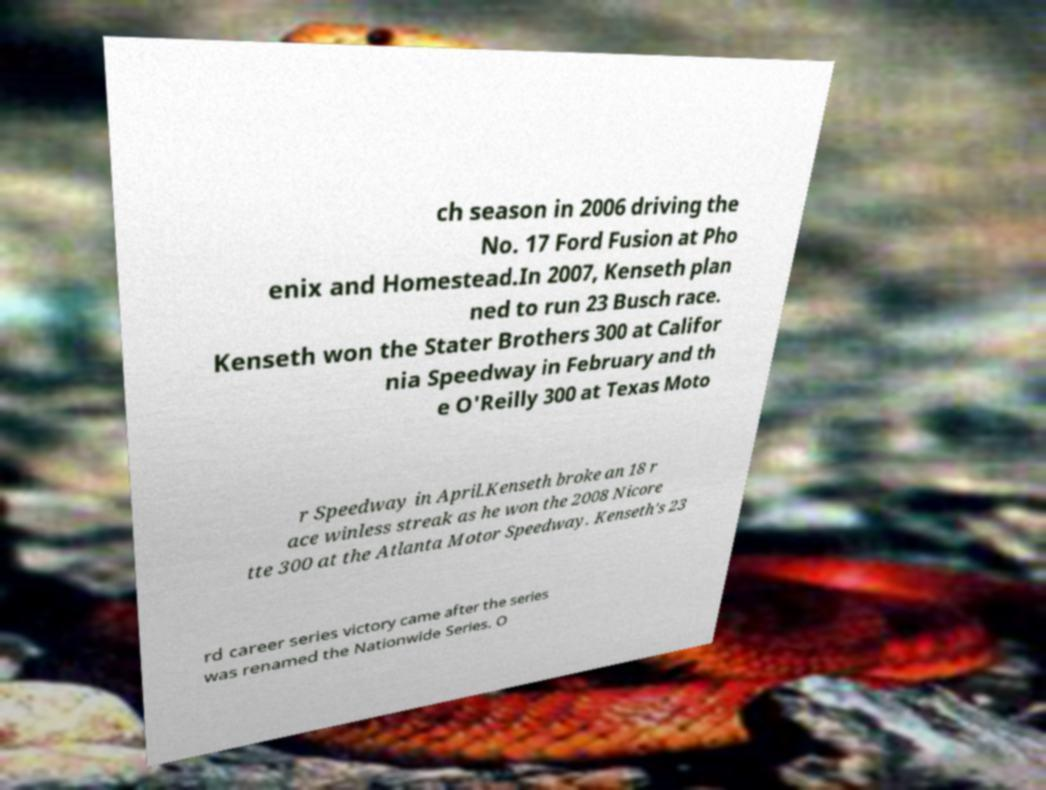Please identify and transcribe the text found in this image. ch season in 2006 driving the No. 17 Ford Fusion at Pho enix and Homestead.In 2007, Kenseth plan ned to run 23 Busch race. Kenseth won the Stater Brothers 300 at Califor nia Speedway in February and th e O'Reilly 300 at Texas Moto r Speedway in April.Kenseth broke an 18 r ace winless streak as he won the 2008 Nicore tte 300 at the Atlanta Motor Speedway. Kenseth's 23 rd career series victory came after the series was renamed the Nationwide Series. O 